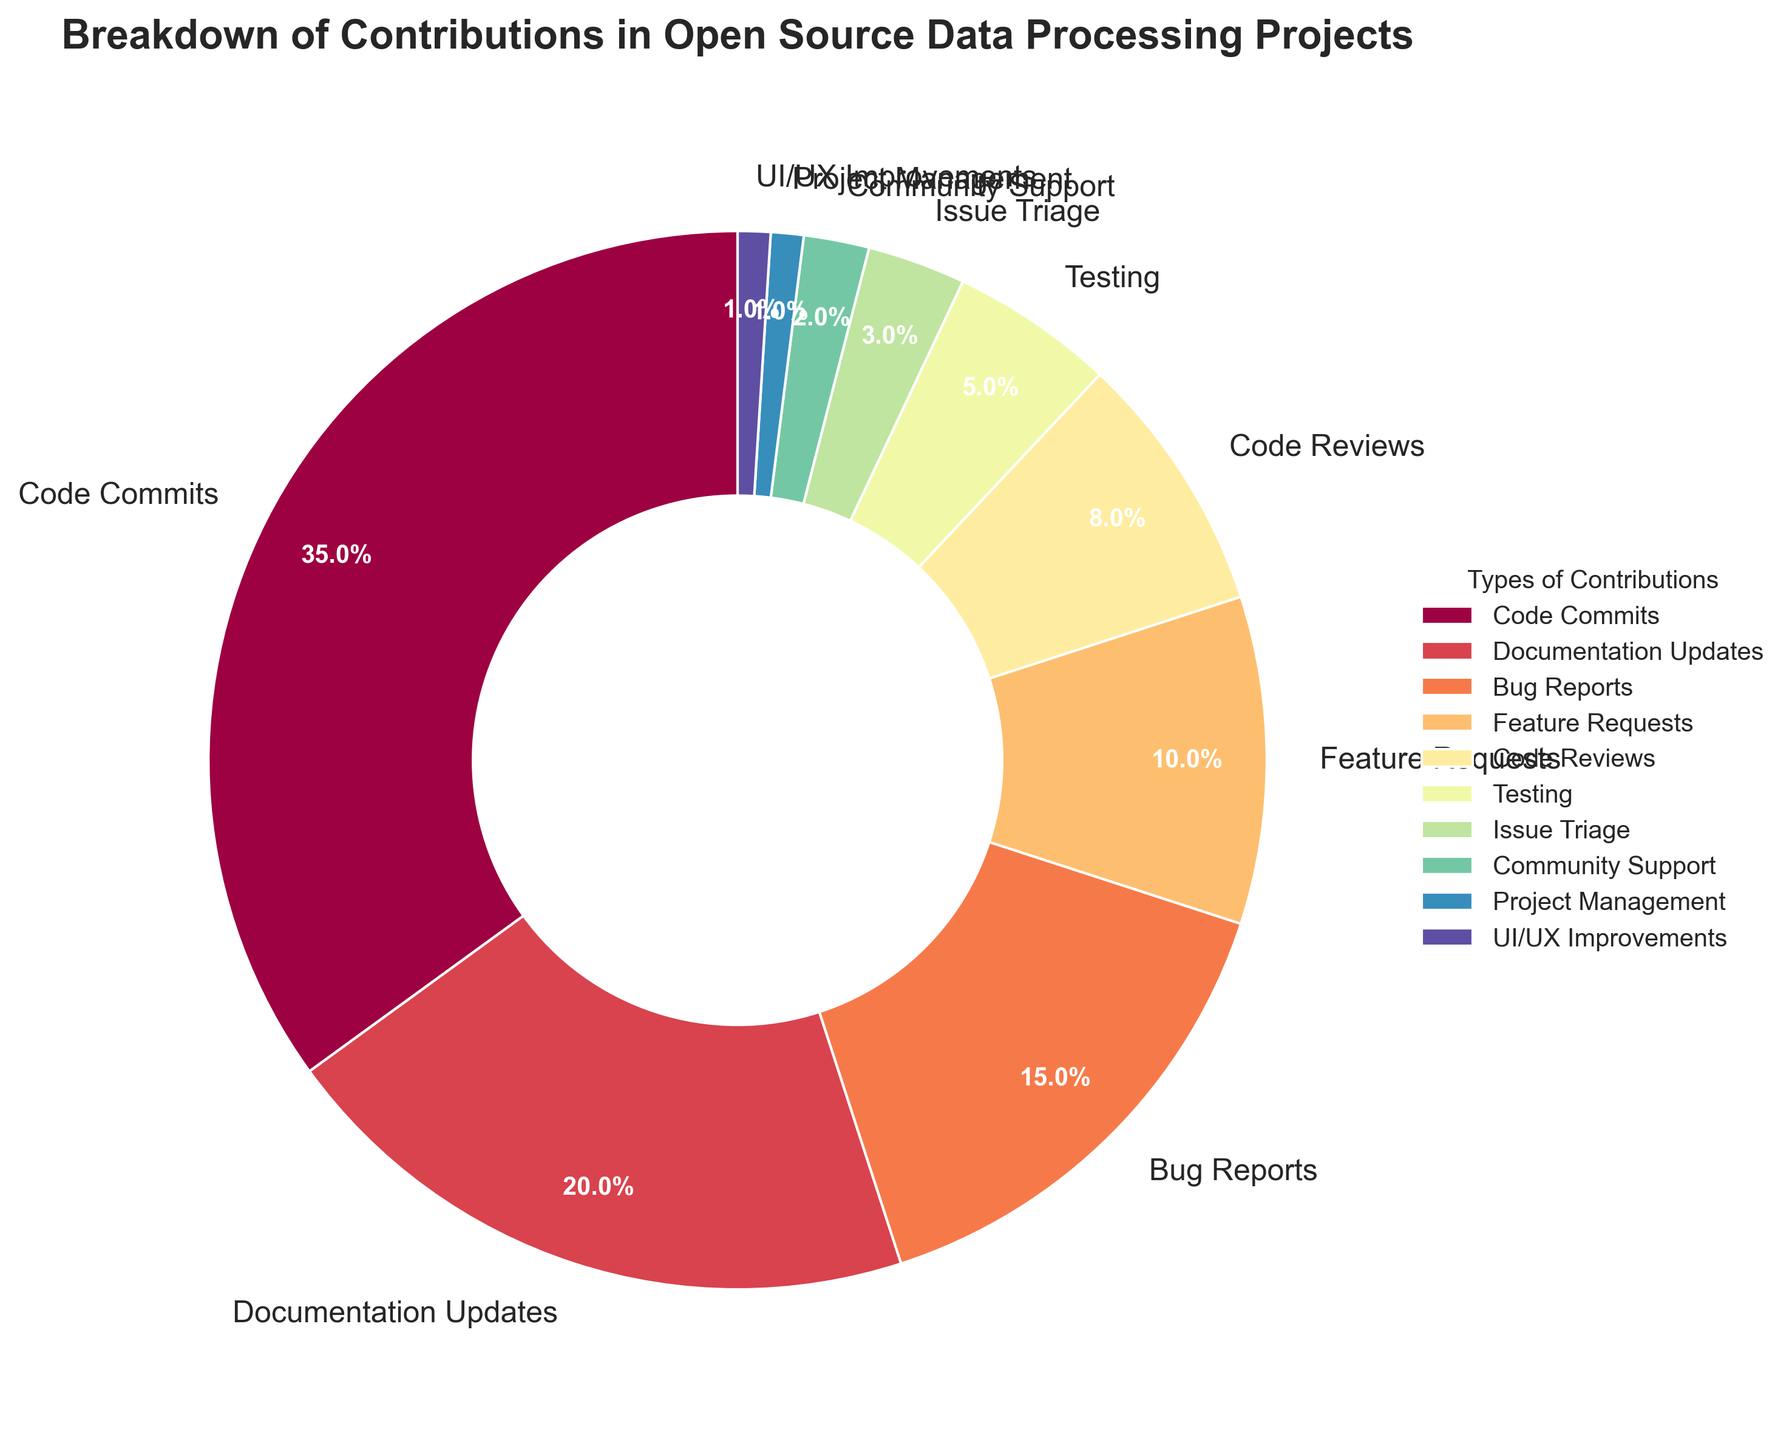What percentage of contributions are related to code activities (including Code Commits, Code Reviews, and Testing)? Code Commits are 35%, Code Reviews are 8%, and Testing is 5%. Adding them together: 35% + 8% + 5% = 48%
Answer: 48% Which type of contribution has the highest percentage in the pie chart? The largest wedge in the pie chart is labeled "Code Commits"
Answer: Code Commits What is the total percentage of contributions that fall under non-code activities (excluding Code Commits, Code Reviews, and Testing)? Sum the percentages of Documentation Updates (20%), Bug Reports (15%), Feature Requests (10%), Issue Triage (3%), Community Support (2%), Project Management (1%), and UI/UX Improvements (1%): 20% + 15% + 10% + 3% + 2% + 1% + 1% = 52%
Answer: 52% Are Documentation Updates more frequent than Bug Reports and Feature Requests combined? Bug Reports and Feature Requests combined are 15% + 10% = 25%. Documentation Updates are 20%. 20% < 25%
Answer: No How does the percentage of Community Support contributions compare to that of Project Management? From the chart, Community Support is 2% and Project Management is 1%. 2% is greater than 1%
Answer: Community Support is greater Which sections of the pie chart are represented by the smallest wedges, and what are their percentages? The smallest wedges are for Project Management and UI/UX Improvements, both at 1%
Answer: Project Management (1%) and UI/UX Improvements (1%) What is the combined percentage of Bug Reports and Code Reviews? Bug Reports are 15%, and Code Reviews are 8%. Adding them together: 15% + 8% = 23%
Answer: 23% If Documentation Updates increased by 5%, what would the new total percentage of contributions be? Current Documentation Updates are 20%, an additional 5% makes it 25%. Adding this to the original total of 100%, we get 105%
Answer: 105% Which type of contribution is less than half the percentage of Code Commits? Code Commits are 35%. Half of 35% is 17.5%. All contributions less than this are: Bug Reports (15%), Feature Requests (10%), Code Reviews (8%), Testing (5%), Issue Triage (3%), Community Support (2%), Project Management (1%), and UI/UX Improvements (1%)
Answer: Bug Reports, Feature Requests, Code Reviews, Testing, Issue Triage, Community Support, Project Management, UI/UX Improvements What's the ratio of Code Commits to Community Support contributions? Code Commits are 35%, and Community Support is 2%. The ratio is 35:2, which can be simplified to 17.5:1
Answer: 17.5:1 